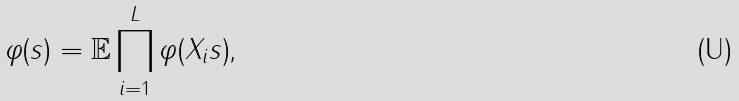Convert formula to latex. <formula><loc_0><loc_0><loc_500><loc_500>\varphi ( s ) = \mathbb { E } \prod _ { i = 1 } ^ { L } \varphi ( X _ { i } s ) \text {,}</formula> 